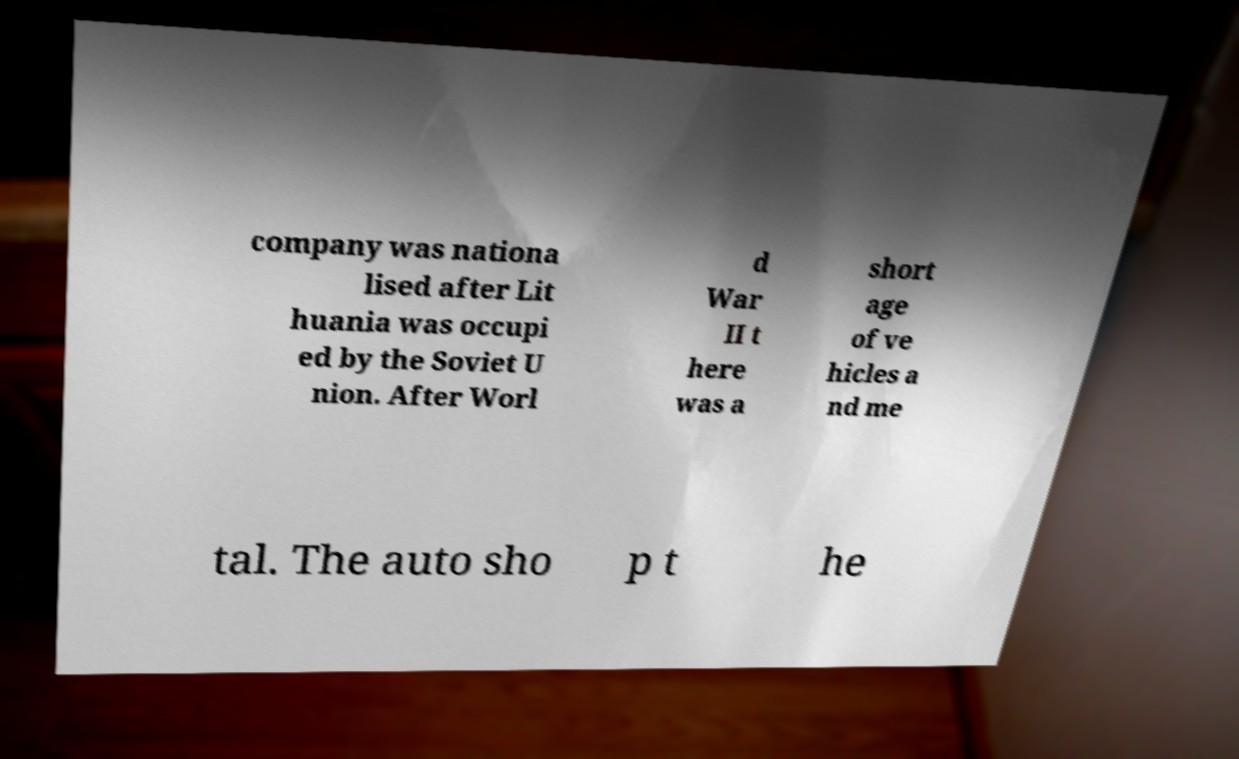For documentation purposes, I need the text within this image transcribed. Could you provide that? company was nationa lised after Lit huania was occupi ed by the Soviet U nion. After Worl d War II t here was a short age of ve hicles a nd me tal. The auto sho p t he 